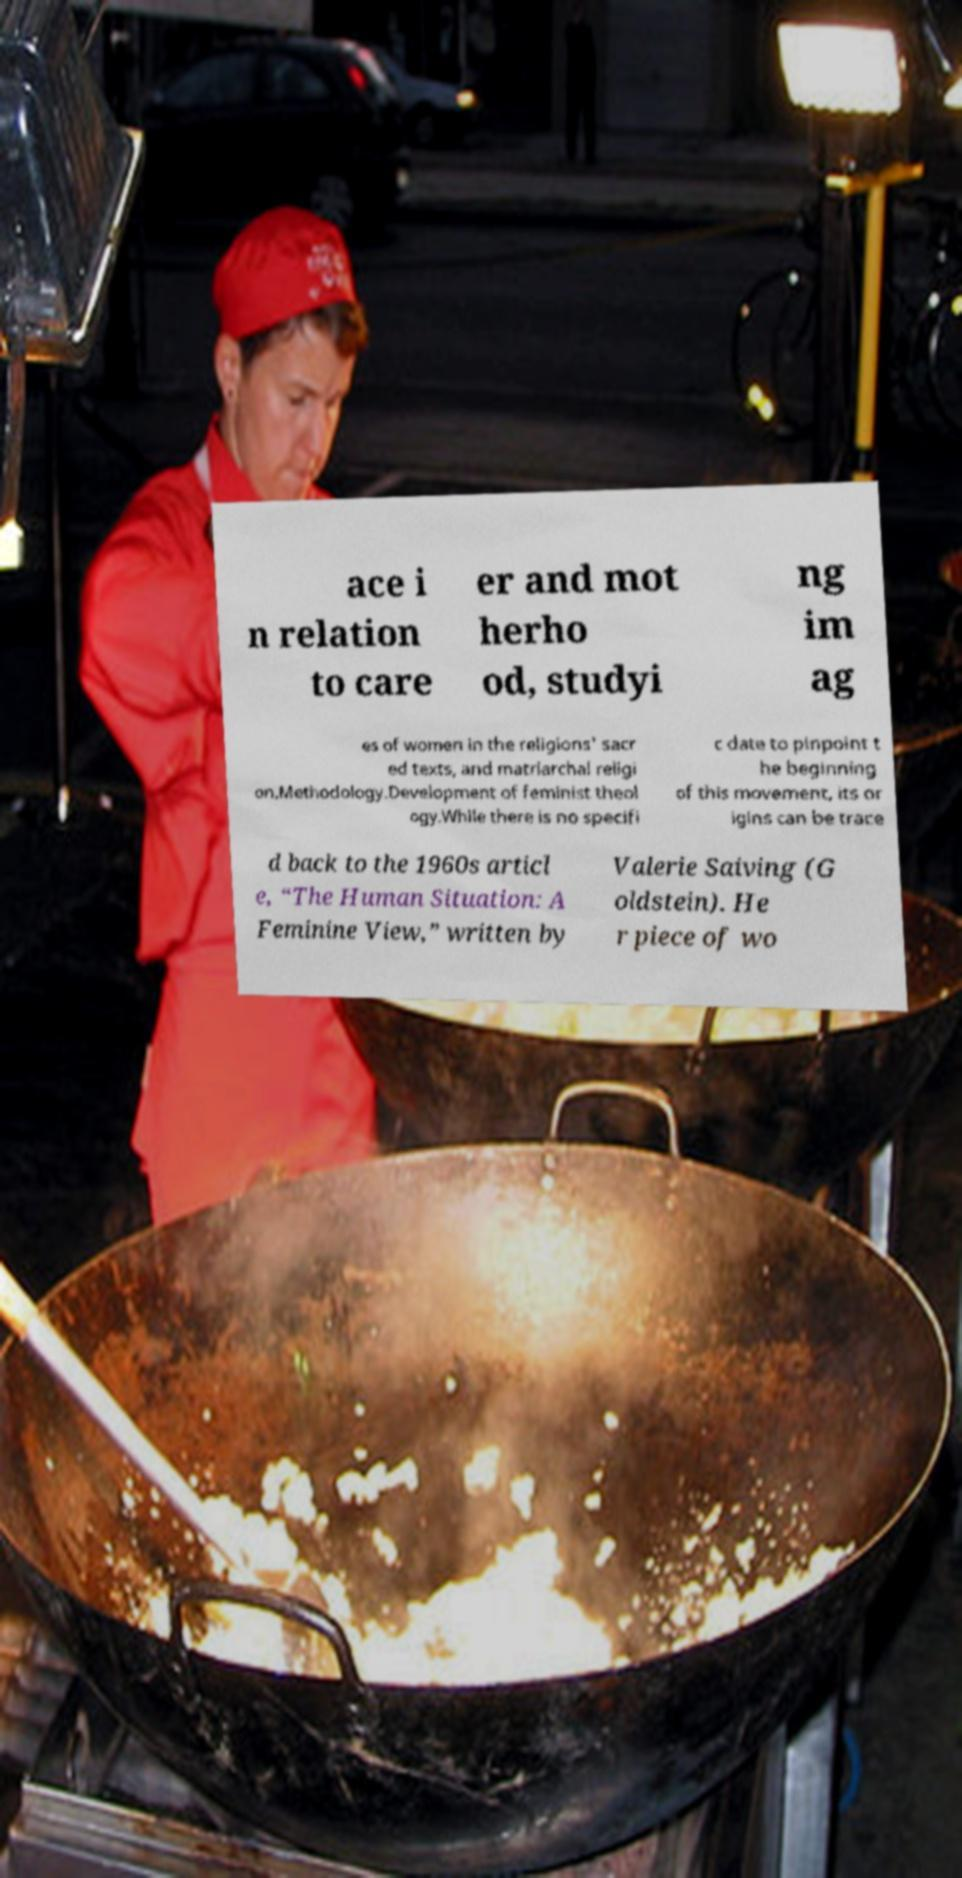For documentation purposes, I need the text within this image transcribed. Could you provide that? ace i n relation to care er and mot herho od, studyi ng im ag es of women in the religions' sacr ed texts, and matriarchal religi on.Methodology.Development of feminist theol ogy.While there is no specifi c date to pinpoint t he beginning of this movement, its or igins can be trace d back to the 1960s articl e, “The Human Situation: A Feminine View,” written by Valerie Saiving (G oldstein). He r piece of wo 